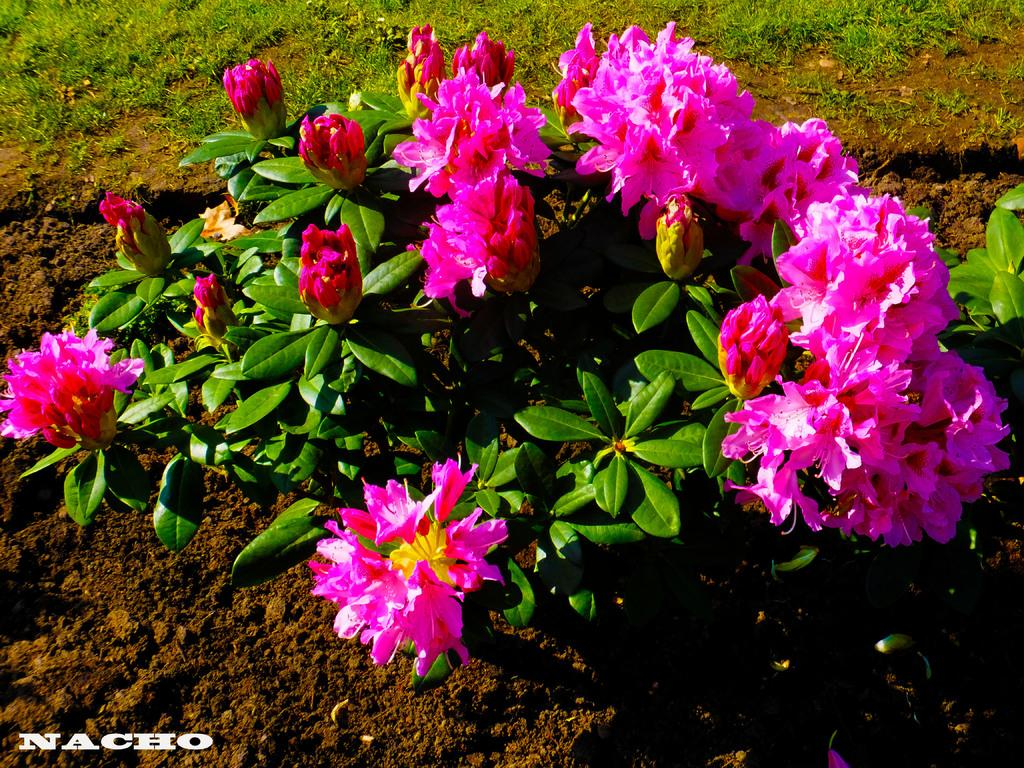What type of plants can be seen in the image? There are plants with flowers in the image. What type of vegetation is present in the image besides the plants? There is grass in the image. How many ducks are sitting on the rod in the image? There are no ducks or rods present in the image. 